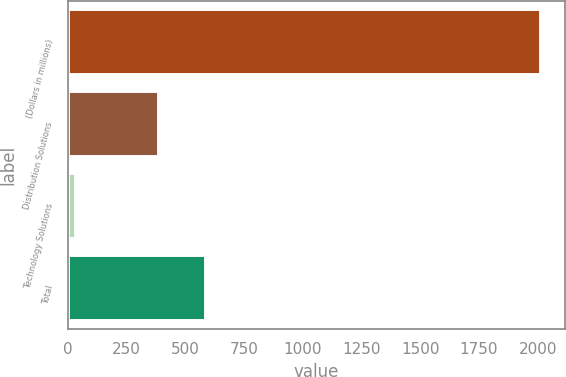Convert chart. <chart><loc_0><loc_0><loc_500><loc_500><bar_chart><fcel>(Dollars in millions)<fcel>Distribution Solutions<fcel>Technology Solutions<fcel>Total<nl><fcel>2016<fcel>389<fcel>34<fcel>587.2<nl></chart> 